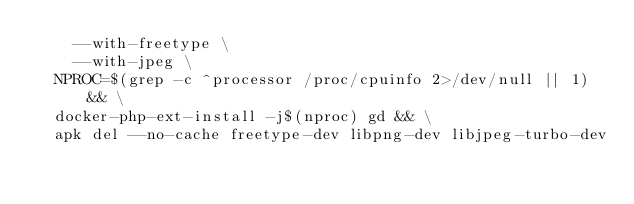<code> <loc_0><loc_0><loc_500><loc_500><_Dockerfile_>    --with-freetype \
    --with-jpeg \
  NPROC=$(grep -c ^processor /proc/cpuinfo 2>/dev/null || 1) && \
  docker-php-ext-install -j$(nproc) gd && \
  apk del --no-cache freetype-dev libpng-dev libjpeg-turbo-dev</code> 